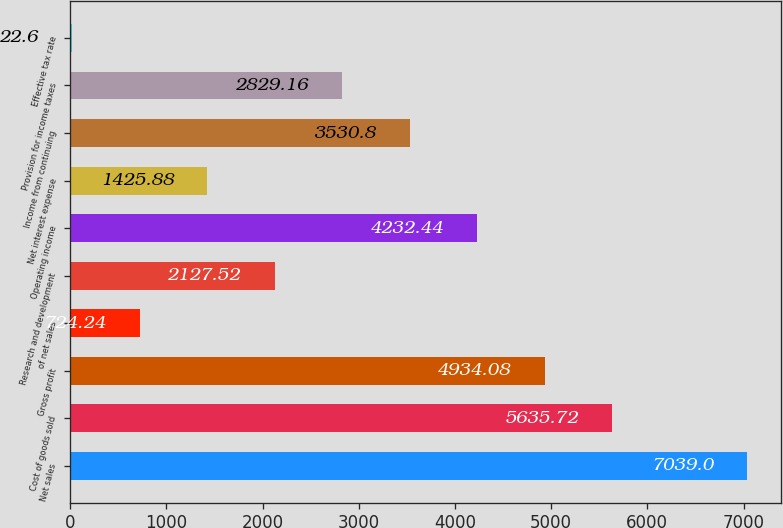Convert chart to OTSL. <chart><loc_0><loc_0><loc_500><loc_500><bar_chart><fcel>Net sales<fcel>Cost of goods sold<fcel>Gross profit<fcel>of net sales<fcel>Research and development<fcel>Operating income<fcel>Net interest expense<fcel>Income from continuing<fcel>Provision for income taxes<fcel>Effective tax rate<nl><fcel>7039<fcel>5635.72<fcel>4934.08<fcel>724.24<fcel>2127.52<fcel>4232.44<fcel>1425.88<fcel>3530.8<fcel>2829.16<fcel>22.6<nl></chart> 